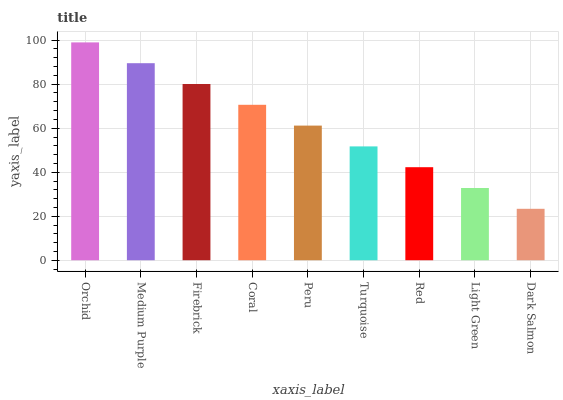Is Medium Purple the minimum?
Answer yes or no. No. Is Medium Purple the maximum?
Answer yes or no. No. Is Orchid greater than Medium Purple?
Answer yes or no. Yes. Is Medium Purple less than Orchid?
Answer yes or no. Yes. Is Medium Purple greater than Orchid?
Answer yes or no. No. Is Orchid less than Medium Purple?
Answer yes or no. No. Is Peru the high median?
Answer yes or no. Yes. Is Peru the low median?
Answer yes or no. Yes. Is Light Green the high median?
Answer yes or no. No. Is Red the low median?
Answer yes or no. No. 